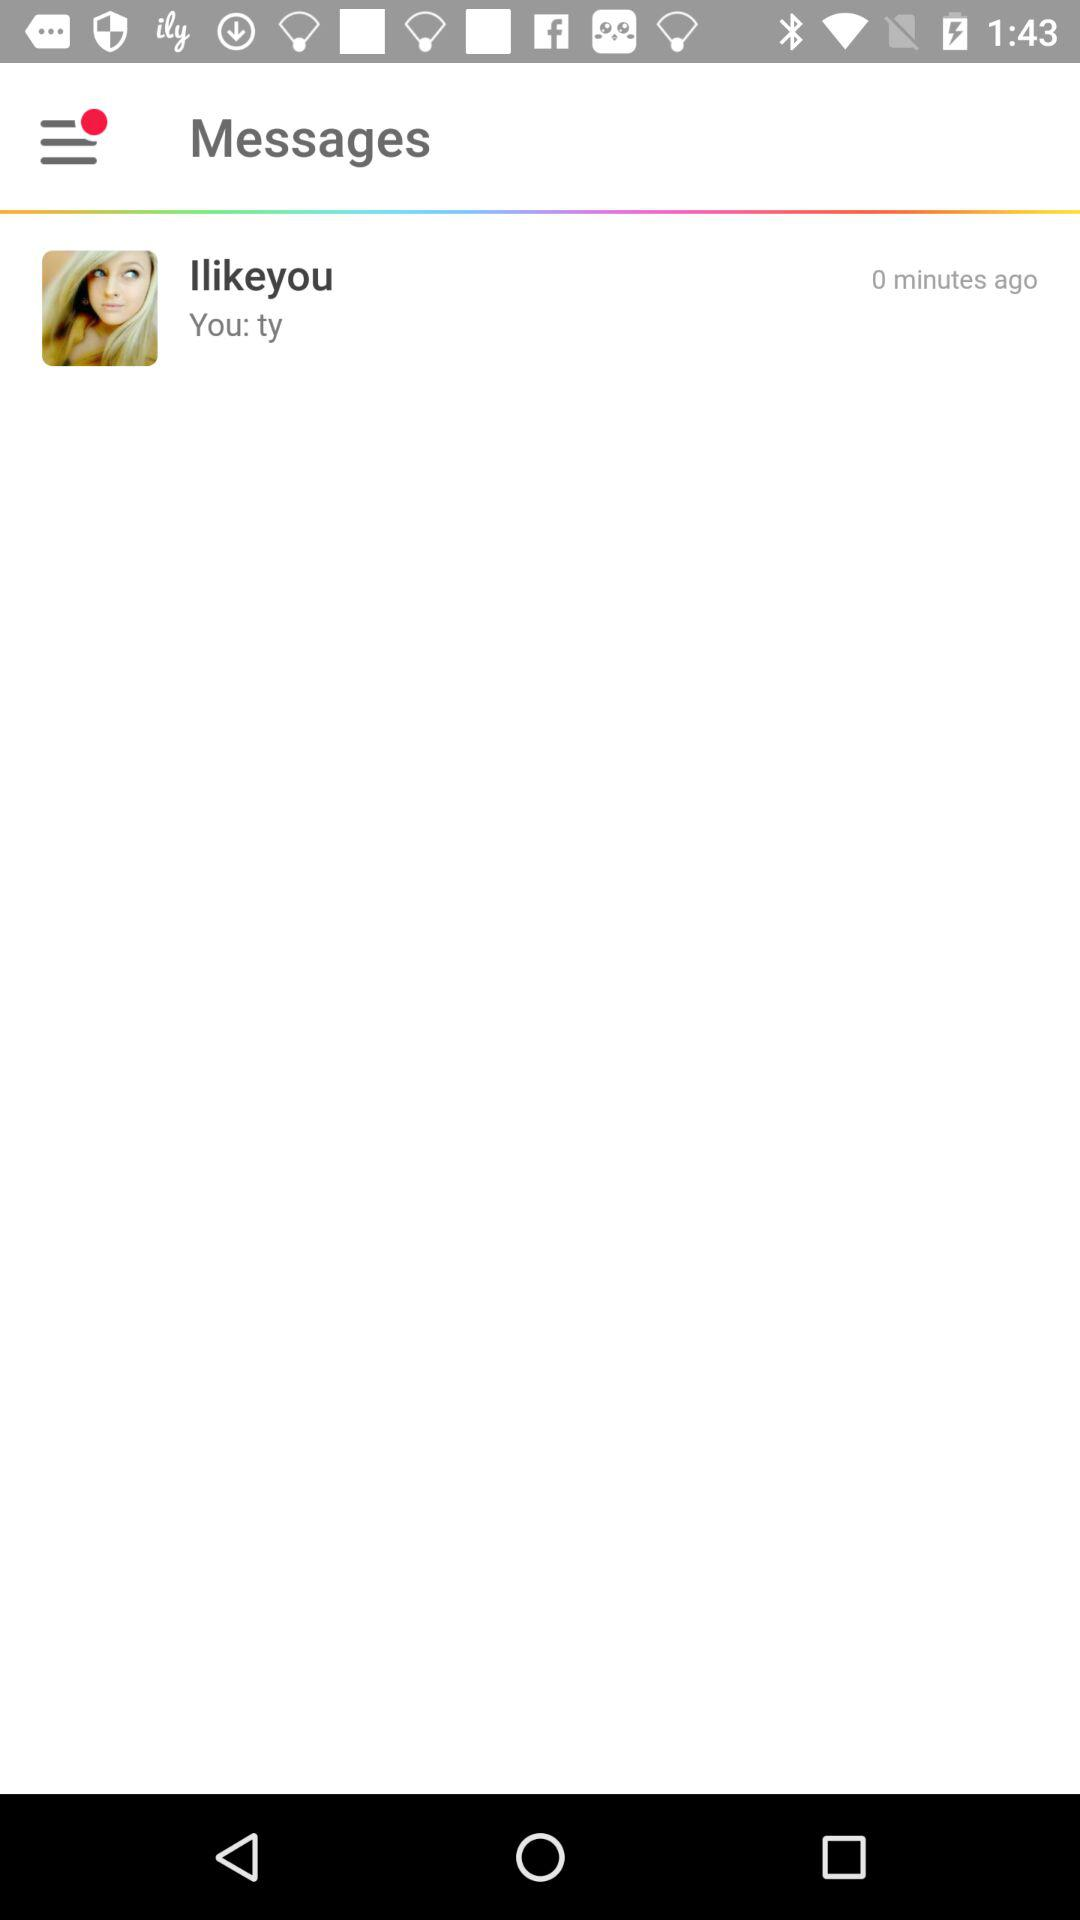Which messaging application is this?
When the provided information is insufficient, respond with <no answer>. <no answer> 